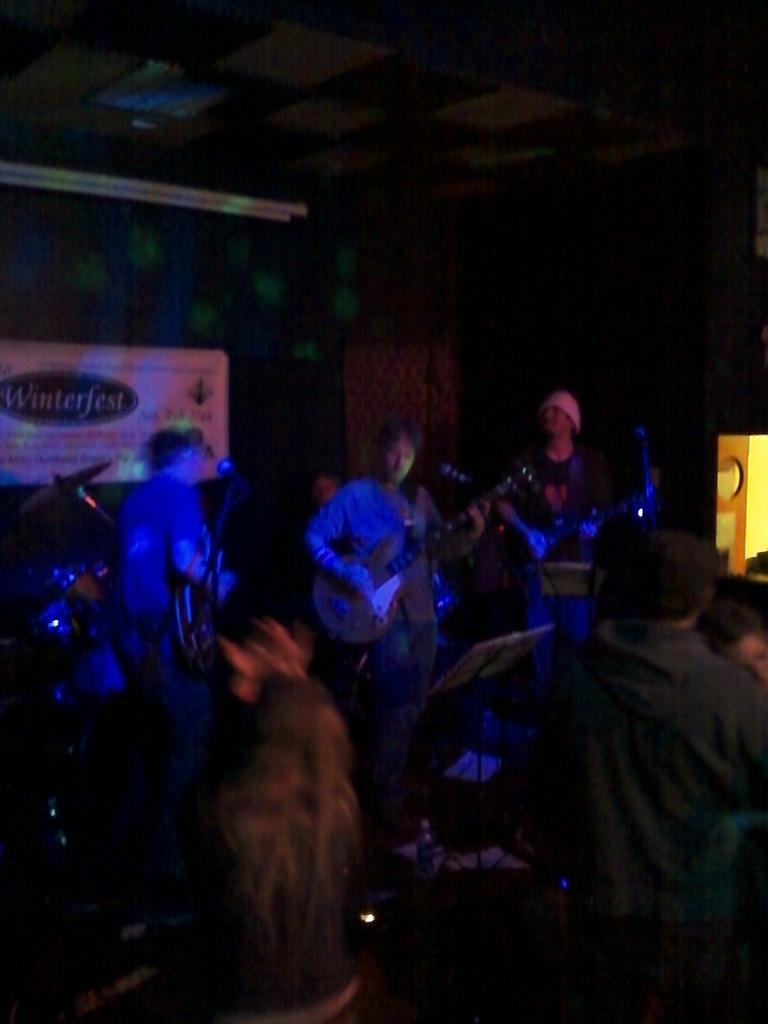What is happening in the image? There is an event in the image. What are the people at the event doing? People are playing music instruments. How is the focus on the people playing music instruments highlighted? There is a blue light focusing on the people playing music instruments. What can be seen behind the people playing music instruments? There is a banner behind the people. What type of birthday cake is placed in the middle of the image? There is no birthday cake present in the image; it features people playing music instruments with a blue light focusing on them and a banner behind them. 